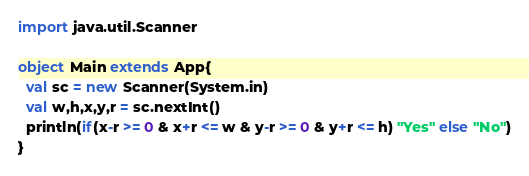Convert code to text. <code><loc_0><loc_0><loc_500><loc_500><_Scala_>import java.util.Scanner

object Main extends App{
  val sc = new Scanner(System.in)
  val w,h,x,y,r = sc.nextInt()
  println(if(x-r >= 0 & x+r <= w & y-r >= 0 & y+r <= h) "Yes" else "No")
}</code> 